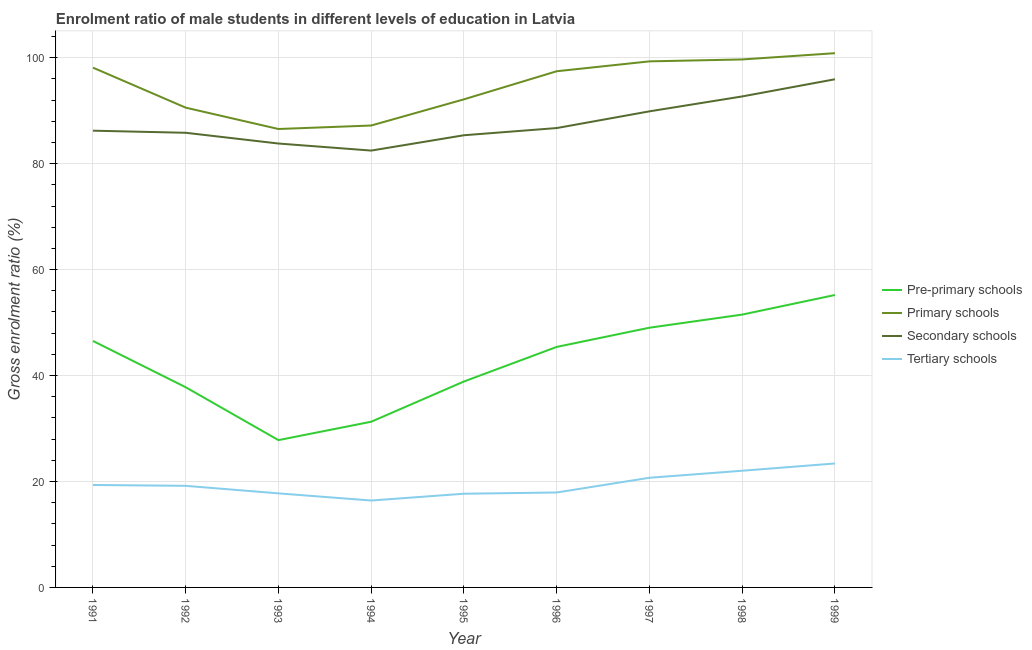How many different coloured lines are there?
Provide a succinct answer. 4. Is the number of lines equal to the number of legend labels?
Your answer should be very brief. Yes. What is the gross enrolment ratio(female) in secondary schools in 1993?
Offer a very short reply. 83.8. Across all years, what is the maximum gross enrolment ratio(female) in tertiary schools?
Give a very brief answer. 23.4. Across all years, what is the minimum gross enrolment ratio(female) in tertiary schools?
Offer a very short reply. 16.41. In which year was the gross enrolment ratio(female) in secondary schools minimum?
Offer a very short reply. 1994. What is the total gross enrolment ratio(female) in pre-primary schools in the graph?
Provide a short and direct response. 383.44. What is the difference between the gross enrolment ratio(female) in secondary schools in 1993 and that in 1998?
Offer a very short reply. -8.89. What is the difference between the gross enrolment ratio(female) in pre-primary schools in 1999 and the gross enrolment ratio(female) in secondary schools in 1998?
Offer a terse response. -37.49. What is the average gross enrolment ratio(female) in pre-primary schools per year?
Make the answer very short. 42.6. In the year 1991, what is the difference between the gross enrolment ratio(female) in pre-primary schools and gross enrolment ratio(female) in secondary schools?
Your answer should be compact. -39.69. In how many years, is the gross enrolment ratio(female) in primary schools greater than 16 %?
Your answer should be compact. 9. What is the ratio of the gross enrolment ratio(female) in tertiary schools in 1996 to that in 1997?
Make the answer very short. 0.87. What is the difference between the highest and the second highest gross enrolment ratio(female) in pre-primary schools?
Offer a terse response. 3.7. What is the difference between the highest and the lowest gross enrolment ratio(female) in tertiary schools?
Make the answer very short. 6.99. Is it the case that in every year, the sum of the gross enrolment ratio(female) in tertiary schools and gross enrolment ratio(female) in pre-primary schools is greater than the sum of gross enrolment ratio(female) in primary schools and gross enrolment ratio(female) in secondary schools?
Your response must be concise. No. Does the gross enrolment ratio(female) in tertiary schools monotonically increase over the years?
Offer a terse response. No. Is the gross enrolment ratio(female) in secondary schools strictly greater than the gross enrolment ratio(female) in tertiary schools over the years?
Your answer should be very brief. Yes. Is the gross enrolment ratio(female) in tertiary schools strictly less than the gross enrolment ratio(female) in pre-primary schools over the years?
Your response must be concise. Yes. Are the values on the major ticks of Y-axis written in scientific E-notation?
Give a very brief answer. No. Does the graph contain any zero values?
Your response must be concise. No. Does the graph contain grids?
Provide a short and direct response. Yes. How are the legend labels stacked?
Ensure brevity in your answer.  Vertical. What is the title of the graph?
Give a very brief answer. Enrolment ratio of male students in different levels of education in Latvia. Does "Labor Taxes" appear as one of the legend labels in the graph?
Your response must be concise. No. What is the label or title of the X-axis?
Make the answer very short. Year. What is the Gross enrolment ratio (%) in Pre-primary schools in 1991?
Make the answer very short. 46.53. What is the Gross enrolment ratio (%) of Primary schools in 1991?
Give a very brief answer. 98.13. What is the Gross enrolment ratio (%) in Secondary schools in 1991?
Make the answer very short. 86.23. What is the Gross enrolment ratio (%) in Tertiary schools in 1991?
Keep it short and to the point. 19.34. What is the Gross enrolment ratio (%) in Pre-primary schools in 1992?
Make the answer very short. 37.79. What is the Gross enrolment ratio (%) in Primary schools in 1992?
Your response must be concise. 90.57. What is the Gross enrolment ratio (%) in Secondary schools in 1992?
Your answer should be compact. 85.83. What is the Gross enrolment ratio (%) in Tertiary schools in 1992?
Provide a short and direct response. 19.18. What is the Gross enrolment ratio (%) of Pre-primary schools in 1993?
Your response must be concise. 27.81. What is the Gross enrolment ratio (%) of Primary schools in 1993?
Your answer should be compact. 86.54. What is the Gross enrolment ratio (%) in Secondary schools in 1993?
Offer a terse response. 83.8. What is the Gross enrolment ratio (%) of Tertiary schools in 1993?
Your response must be concise. 17.76. What is the Gross enrolment ratio (%) of Pre-primary schools in 1994?
Your answer should be very brief. 31.28. What is the Gross enrolment ratio (%) in Primary schools in 1994?
Your response must be concise. 87.2. What is the Gross enrolment ratio (%) of Secondary schools in 1994?
Make the answer very short. 82.47. What is the Gross enrolment ratio (%) of Tertiary schools in 1994?
Make the answer very short. 16.41. What is the Gross enrolment ratio (%) of Pre-primary schools in 1995?
Provide a short and direct response. 38.88. What is the Gross enrolment ratio (%) in Primary schools in 1995?
Offer a very short reply. 92.15. What is the Gross enrolment ratio (%) of Secondary schools in 1995?
Offer a very short reply. 85.37. What is the Gross enrolment ratio (%) of Tertiary schools in 1995?
Offer a very short reply. 17.69. What is the Gross enrolment ratio (%) in Pre-primary schools in 1996?
Ensure brevity in your answer.  45.4. What is the Gross enrolment ratio (%) of Primary schools in 1996?
Provide a short and direct response. 97.45. What is the Gross enrolment ratio (%) of Secondary schools in 1996?
Offer a terse response. 86.72. What is the Gross enrolment ratio (%) of Tertiary schools in 1996?
Offer a terse response. 17.92. What is the Gross enrolment ratio (%) in Pre-primary schools in 1997?
Your response must be concise. 49.03. What is the Gross enrolment ratio (%) in Primary schools in 1997?
Your answer should be compact. 99.31. What is the Gross enrolment ratio (%) in Secondary schools in 1997?
Provide a short and direct response. 89.88. What is the Gross enrolment ratio (%) in Tertiary schools in 1997?
Offer a very short reply. 20.7. What is the Gross enrolment ratio (%) of Pre-primary schools in 1998?
Your answer should be compact. 51.51. What is the Gross enrolment ratio (%) of Primary schools in 1998?
Offer a very short reply. 99.67. What is the Gross enrolment ratio (%) in Secondary schools in 1998?
Make the answer very short. 92.69. What is the Gross enrolment ratio (%) of Tertiary schools in 1998?
Ensure brevity in your answer.  22.03. What is the Gross enrolment ratio (%) in Pre-primary schools in 1999?
Your response must be concise. 55.2. What is the Gross enrolment ratio (%) in Primary schools in 1999?
Your answer should be compact. 100.86. What is the Gross enrolment ratio (%) in Secondary schools in 1999?
Keep it short and to the point. 95.93. What is the Gross enrolment ratio (%) in Tertiary schools in 1999?
Give a very brief answer. 23.4. Across all years, what is the maximum Gross enrolment ratio (%) of Pre-primary schools?
Your answer should be compact. 55.2. Across all years, what is the maximum Gross enrolment ratio (%) of Primary schools?
Offer a terse response. 100.86. Across all years, what is the maximum Gross enrolment ratio (%) in Secondary schools?
Offer a very short reply. 95.93. Across all years, what is the maximum Gross enrolment ratio (%) of Tertiary schools?
Provide a succinct answer. 23.4. Across all years, what is the minimum Gross enrolment ratio (%) of Pre-primary schools?
Provide a short and direct response. 27.81. Across all years, what is the minimum Gross enrolment ratio (%) in Primary schools?
Offer a terse response. 86.54. Across all years, what is the minimum Gross enrolment ratio (%) of Secondary schools?
Offer a terse response. 82.47. Across all years, what is the minimum Gross enrolment ratio (%) of Tertiary schools?
Provide a succinct answer. 16.41. What is the total Gross enrolment ratio (%) of Pre-primary schools in the graph?
Your answer should be compact. 383.44. What is the total Gross enrolment ratio (%) in Primary schools in the graph?
Provide a succinct answer. 851.88. What is the total Gross enrolment ratio (%) of Secondary schools in the graph?
Keep it short and to the point. 788.92. What is the total Gross enrolment ratio (%) of Tertiary schools in the graph?
Ensure brevity in your answer.  174.43. What is the difference between the Gross enrolment ratio (%) in Pre-primary schools in 1991 and that in 1992?
Ensure brevity in your answer.  8.74. What is the difference between the Gross enrolment ratio (%) in Primary schools in 1991 and that in 1992?
Offer a terse response. 7.55. What is the difference between the Gross enrolment ratio (%) of Secondary schools in 1991 and that in 1992?
Offer a terse response. 0.4. What is the difference between the Gross enrolment ratio (%) of Tertiary schools in 1991 and that in 1992?
Offer a very short reply. 0.16. What is the difference between the Gross enrolment ratio (%) in Pre-primary schools in 1991 and that in 1993?
Your answer should be compact. 18.72. What is the difference between the Gross enrolment ratio (%) of Primary schools in 1991 and that in 1993?
Give a very brief answer. 11.59. What is the difference between the Gross enrolment ratio (%) in Secondary schools in 1991 and that in 1993?
Keep it short and to the point. 2.42. What is the difference between the Gross enrolment ratio (%) in Tertiary schools in 1991 and that in 1993?
Give a very brief answer. 1.59. What is the difference between the Gross enrolment ratio (%) of Pre-primary schools in 1991 and that in 1994?
Make the answer very short. 15.25. What is the difference between the Gross enrolment ratio (%) of Primary schools in 1991 and that in 1994?
Offer a very short reply. 10.93. What is the difference between the Gross enrolment ratio (%) of Secondary schools in 1991 and that in 1994?
Your response must be concise. 3.76. What is the difference between the Gross enrolment ratio (%) of Tertiary schools in 1991 and that in 1994?
Offer a very short reply. 2.94. What is the difference between the Gross enrolment ratio (%) in Pre-primary schools in 1991 and that in 1995?
Keep it short and to the point. 7.66. What is the difference between the Gross enrolment ratio (%) in Primary schools in 1991 and that in 1995?
Your response must be concise. 5.98. What is the difference between the Gross enrolment ratio (%) of Secondary schools in 1991 and that in 1995?
Your response must be concise. 0.86. What is the difference between the Gross enrolment ratio (%) of Tertiary schools in 1991 and that in 1995?
Your answer should be compact. 1.65. What is the difference between the Gross enrolment ratio (%) in Pre-primary schools in 1991 and that in 1996?
Offer a very short reply. 1.13. What is the difference between the Gross enrolment ratio (%) in Primary schools in 1991 and that in 1996?
Give a very brief answer. 0.68. What is the difference between the Gross enrolment ratio (%) of Secondary schools in 1991 and that in 1996?
Keep it short and to the point. -0.5. What is the difference between the Gross enrolment ratio (%) in Tertiary schools in 1991 and that in 1996?
Provide a succinct answer. 1.42. What is the difference between the Gross enrolment ratio (%) in Pre-primary schools in 1991 and that in 1997?
Offer a very short reply. -2.5. What is the difference between the Gross enrolment ratio (%) in Primary schools in 1991 and that in 1997?
Your response must be concise. -1.19. What is the difference between the Gross enrolment ratio (%) in Secondary schools in 1991 and that in 1997?
Keep it short and to the point. -3.65. What is the difference between the Gross enrolment ratio (%) of Tertiary schools in 1991 and that in 1997?
Make the answer very short. -1.36. What is the difference between the Gross enrolment ratio (%) in Pre-primary schools in 1991 and that in 1998?
Keep it short and to the point. -4.98. What is the difference between the Gross enrolment ratio (%) in Primary schools in 1991 and that in 1998?
Ensure brevity in your answer.  -1.55. What is the difference between the Gross enrolment ratio (%) of Secondary schools in 1991 and that in 1998?
Keep it short and to the point. -6.47. What is the difference between the Gross enrolment ratio (%) in Tertiary schools in 1991 and that in 1998?
Keep it short and to the point. -2.69. What is the difference between the Gross enrolment ratio (%) in Pre-primary schools in 1991 and that in 1999?
Make the answer very short. -8.67. What is the difference between the Gross enrolment ratio (%) in Primary schools in 1991 and that in 1999?
Your response must be concise. -2.73. What is the difference between the Gross enrolment ratio (%) in Secondary schools in 1991 and that in 1999?
Your answer should be compact. -9.71. What is the difference between the Gross enrolment ratio (%) of Tertiary schools in 1991 and that in 1999?
Your response must be concise. -4.05. What is the difference between the Gross enrolment ratio (%) of Pre-primary schools in 1992 and that in 1993?
Keep it short and to the point. 9.99. What is the difference between the Gross enrolment ratio (%) in Primary schools in 1992 and that in 1993?
Your answer should be compact. 4.03. What is the difference between the Gross enrolment ratio (%) in Secondary schools in 1992 and that in 1993?
Provide a short and direct response. 2.03. What is the difference between the Gross enrolment ratio (%) in Tertiary schools in 1992 and that in 1993?
Offer a terse response. 1.42. What is the difference between the Gross enrolment ratio (%) in Pre-primary schools in 1992 and that in 1994?
Your answer should be compact. 6.51. What is the difference between the Gross enrolment ratio (%) of Primary schools in 1992 and that in 1994?
Your answer should be very brief. 3.37. What is the difference between the Gross enrolment ratio (%) of Secondary schools in 1992 and that in 1994?
Offer a very short reply. 3.36. What is the difference between the Gross enrolment ratio (%) of Tertiary schools in 1992 and that in 1994?
Offer a terse response. 2.77. What is the difference between the Gross enrolment ratio (%) of Pre-primary schools in 1992 and that in 1995?
Provide a succinct answer. -1.08. What is the difference between the Gross enrolment ratio (%) of Primary schools in 1992 and that in 1995?
Provide a short and direct response. -1.57. What is the difference between the Gross enrolment ratio (%) of Secondary schools in 1992 and that in 1995?
Your answer should be compact. 0.47. What is the difference between the Gross enrolment ratio (%) of Tertiary schools in 1992 and that in 1995?
Keep it short and to the point. 1.49. What is the difference between the Gross enrolment ratio (%) of Pre-primary schools in 1992 and that in 1996?
Keep it short and to the point. -7.61. What is the difference between the Gross enrolment ratio (%) of Primary schools in 1992 and that in 1996?
Keep it short and to the point. -6.87. What is the difference between the Gross enrolment ratio (%) in Secondary schools in 1992 and that in 1996?
Your response must be concise. -0.89. What is the difference between the Gross enrolment ratio (%) in Tertiary schools in 1992 and that in 1996?
Provide a short and direct response. 1.26. What is the difference between the Gross enrolment ratio (%) in Pre-primary schools in 1992 and that in 1997?
Provide a short and direct response. -11.24. What is the difference between the Gross enrolment ratio (%) in Primary schools in 1992 and that in 1997?
Make the answer very short. -8.74. What is the difference between the Gross enrolment ratio (%) in Secondary schools in 1992 and that in 1997?
Offer a terse response. -4.05. What is the difference between the Gross enrolment ratio (%) of Tertiary schools in 1992 and that in 1997?
Give a very brief answer. -1.52. What is the difference between the Gross enrolment ratio (%) in Pre-primary schools in 1992 and that in 1998?
Ensure brevity in your answer.  -13.71. What is the difference between the Gross enrolment ratio (%) of Primary schools in 1992 and that in 1998?
Offer a very short reply. -9.1. What is the difference between the Gross enrolment ratio (%) in Secondary schools in 1992 and that in 1998?
Offer a very short reply. -6.86. What is the difference between the Gross enrolment ratio (%) of Tertiary schools in 1992 and that in 1998?
Offer a terse response. -2.85. What is the difference between the Gross enrolment ratio (%) of Pre-primary schools in 1992 and that in 1999?
Your answer should be very brief. -17.41. What is the difference between the Gross enrolment ratio (%) in Primary schools in 1992 and that in 1999?
Provide a succinct answer. -10.28. What is the difference between the Gross enrolment ratio (%) in Secondary schools in 1992 and that in 1999?
Ensure brevity in your answer.  -10.1. What is the difference between the Gross enrolment ratio (%) of Tertiary schools in 1992 and that in 1999?
Make the answer very short. -4.22. What is the difference between the Gross enrolment ratio (%) in Pre-primary schools in 1993 and that in 1994?
Give a very brief answer. -3.47. What is the difference between the Gross enrolment ratio (%) of Primary schools in 1993 and that in 1994?
Your response must be concise. -0.66. What is the difference between the Gross enrolment ratio (%) in Secondary schools in 1993 and that in 1994?
Provide a succinct answer. 1.33. What is the difference between the Gross enrolment ratio (%) of Tertiary schools in 1993 and that in 1994?
Make the answer very short. 1.35. What is the difference between the Gross enrolment ratio (%) of Pre-primary schools in 1993 and that in 1995?
Your answer should be compact. -11.07. What is the difference between the Gross enrolment ratio (%) in Primary schools in 1993 and that in 1995?
Keep it short and to the point. -5.6. What is the difference between the Gross enrolment ratio (%) of Secondary schools in 1993 and that in 1995?
Offer a terse response. -1.56. What is the difference between the Gross enrolment ratio (%) of Tertiary schools in 1993 and that in 1995?
Offer a terse response. 0.07. What is the difference between the Gross enrolment ratio (%) in Pre-primary schools in 1993 and that in 1996?
Provide a short and direct response. -17.59. What is the difference between the Gross enrolment ratio (%) in Primary schools in 1993 and that in 1996?
Keep it short and to the point. -10.9. What is the difference between the Gross enrolment ratio (%) of Secondary schools in 1993 and that in 1996?
Ensure brevity in your answer.  -2.92. What is the difference between the Gross enrolment ratio (%) in Tertiary schools in 1993 and that in 1996?
Offer a very short reply. -0.17. What is the difference between the Gross enrolment ratio (%) of Pre-primary schools in 1993 and that in 1997?
Your response must be concise. -21.22. What is the difference between the Gross enrolment ratio (%) in Primary schools in 1993 and that in 1997?
Make the answer very short. -12.77. What is the difference between the Gross enrolment ratio (%) of Secondary schools in 1993 and that in 1997?
Your answer should be compact. -6.08. What is the difference between the Gross enrolment ratio (%) in Tertiary schools in 1993 and that in 1997?
Keep it short and to the point. -2.95. What is the difference between the Gross enrolment ratio (%) in Pre-primary schools in 1993 and that in 1998?
Ensure brevity in your answer.  -23.7. What is the difference between the Gross enrolment ratio (%) of Primary schools in 1993 and that in 1998?
Make the answer very short. -13.13. What is the difference between the Gross enrolment ratio (%) of Secondary schools in 1993 and that in 1998?
Keep it short and to the point. -8.89. What is the difference between the Gross enrolment ratio (%) of Tertiary schools in 1993 and that in 1998?
Provide a succinct answer. -4.27. What is the difference between the Gross enrolment ratio (%) in Pre-primary schools in 1993 and that in 1999?
Ensure brevity in your answer.  -27.39. What is the difference between the Gross enrolment ratio (%) in Primary schools in 1993 and that in 1999?
Your answer should be compact. -14.31. What is the difference between the Gross enrolment ratio (%) in Secondary schools in 1993 and that in 1999?
Make the answer very short. -12.13. What is the difference between the Gross enrolment ratio (%) in Tertiary schools in 1993 and that in 1999?
Your answer should be compact. -5.64. What is the difference between the Gross enrolment ratio (%) of Pre-primary schools in 1994 and that in 1995?
Your response must be concise. -7.6. What is the difference between the Gross enrolment ratio (%) of Primary schools in 1994 and that in 1995?
Make the answer very short. -4.94. What is the difference between the Gross enrolment ratio (%) in Secondary schools in 1994 and that in 1995?
Your response must be concise. -2.89. What is the difference between the Gross enrolment ratio (%) in Tertiary schools in 1994 and that in 1995?
Offer a terse response. -1.28. What is the difference between the Gross enrolment ratio (%) in Pre-primary schools in 1994 and that in 1996?
Offer a terse response. -14.12. What is the difference between the Gross enrolment ratio (%) of Primary schools in 1994 and that in 1996?
Offer a terse response. -10.24. What is the difference between the Gross enrolment ratio (%) in Secondary schools in 1994 and that in 1996?
Ensure brevity in your answer.  -4.25. What is the difference between the Gross enrolment ratio (%) in Tertiary schools in 1994 and that in 1996?
Ensure brevity in your answer.  -1.52. What is the difference between the Gross enrolment ratio (%) in Pre-primary schools in 1994 and that in 1997?
Keep it short and to the point. -17.75. What is the difference between the Gross enrolment ratio (%) in Primary schools in 1994 and that in 1997?
Provide a succinct answer. -12.11. What is the difference between the Gross enrolment ratio (%) in Secondary schools in 1994 and that in 1997?
Your response must be concise. -7.41. What is the difference between the Gross enrolment ratio (%) in Tertiary schools in 1994 and that in 1997?
Provide a short and direct response. -4.29. What is the difference between the Gross enrolment ratio (%) in Pre-primary schools in 1994 and that in 1998?
Give a very brief answer. -20.23. What is the difference between the Gross enrolment ratio (%) of Primary schools in 1994 and that in 1998?
Your answer should be compact. -12.47. What is the difference between the Gross enrolment ratio (%) in Secondary schools in 1994 and that in 1998?
Provide a succinct answer. -10.22. What is the difference between the Gross enrolment ratio (%) in Tertiary schools in 1994 and that in 1998?
Provide a succinct answer. -5.62. What is the difference between the Gross enrolment ratio (%) of Pre-primary schools in 1994 and that in 1999?
Offer a terse response. -23.92. What is the difference between the Gross enrolment ratio (%) in Primary schools in 1994 and that in 1999?
Give a very brief answer. -13.65. What is the difference between the Gross enrolment ratio (%) of Secondary schools in 1994 and that in 1999?
Make the answer very short. -13.46. What is the difference between the Gross enrolment ratio (%) of Tertiary schools in 1994 and that in 1999?
Make the answer very short. -6.99. What is the difference between the Gross enrolment ratio (%) of Pre-primary schools in 1995 and that in 1996?
Your answer should be compact. -6.53. What is the difference between the Gross enrolment ratio (%) in Primary schools in 1995 and that in 1996?
Your answer should be compact. -5.3. What is the difference between the Gross enrolment ratio (%) in Secondary schools in 1995 and that in 1996?
Your answer should be compact. -1.36. What is the difference between the Gross enrolment ratio (%) of Tertiary schools in 1995 and that in 1996?
Your answer should be very brief. -0.23. What is the difference between the Gross enrolment ratio (%) in Pre-primary schools in 1995 and that in 1997?
Your answer should be very brief. -10.15. What is the difference between the Gross enrolment ratio (%) of Primary schools in 1995 and that in 1997?
Your answer should be very brief. -7.17. What is the difference between the Gross enrolment ratio (%) of Secondary schools in 1995 and that in 1997?
Offer a very short reply. -4.51. What is the difference between the Gross enrolment ratio (%) in Tertiary schools in 1995 and that in 1997?
Your answer should be very brief. -3.01. What is the difference between the Gross enrolment ratio (%) in Pre-primary schools in 1995 and that in 1998?
Provide a short and direct response. -12.63. What is the difference between the Gross enrolment ratio (%) in Primary schools in 1995 and that in 1998?
Give a very brief answer. -7.53. What is the difference between the Gross enrolment ratio (%) of Secondary schools in 1995 and that in 1998?
Offer a very short reply. -7.33. What is the difference between the Gross enrolment ratio (%) in Tertiary schools in 1995 and that in 1998?
Your answer should be compact. -4.34. What is the difference between the Gross enrolment ratio (%) of Pre-primary schools in 1995 and that in 1999?
Give a very brief answer. -16.33. What is the difference between the Gross enrolment ratio (%) in Primary schools in 1995 and that in 1999?
Your response must be concise. -8.71. What is the difference between the Gross enrolment ratio (%) of Secondary schools in 1995 and that in 1999?
Your answer should be compact. -10.57. What is the difference between the Gross enrolment ratio (%) in Tertiary schools in 1995 and that in 1999?
Keep it short and to the point. -5.71. What is the difference between the Gross enrolment ratio (%) of Pre-primary schools in 1996 and that in 1997?
Keep it short and to the point. -3.63. What is the difference between the Gross enrolment ratio (%) in Primary schools in 1996 and that in 1997?
Your answer should be compact. -1.87. What is the difference between the Gross enrolment ratio (%) in Secondary schools in 1996 and that in 1997?
Give a very brief answer. -3.16. What is the difference between the Gross enrolment ratio (%) of Tertiary schools in 1996 and that in 1997?
Give a very brief answer. -2.78. What is the difference between the Gross enrolment ratio (%) of Pre-primary schools in 1996 and that in 1998?
Keep it short and to the point. -6.1. What is the difference between the Gross enrolment ratio (%) of Primary schools in 1996 and that in 1998?
Your answer should be compact. -2.23. What is the difference between the Gross enrolment ratio (%) of Secondary schools in 1996 and that in 1998?
Provide a short and direct response. -5.97. What is the difference between the Gross enrolment ratio (%) of Tertiary schools in 1996 and that in 1998?
Provide a succinct answer. -4.11. What is the difference between the Gross enrolment ratio (%) of Pre-primary schools in 1996 and that in 1999?
Provide a succinct answer. -9.8. What is the difference between the Gross enrolment ratio (%) of Primary schools in 1996 and that in 1999?
Your answer should be very brief. -3.41. What is the difference between the Gross enrolment ratio (%) in Secondary schools in 1996 and that in 1999?
Make the answer very short. -9.21. What is the difference between the Gross enrolment ratio (%) in Tertiary schools in 1996 and that in 1999?
Your answer should be very brief. -5.48. What is the difference between the Gross enrolment ratio (%) of Pre-primary schools in 1997 and that in 1998?
Offer a very short reply. -2.48. What is the difference between the Gross enrolment ratio (%) in Primary schools in 1997 and that in 1998?
Your answer should be very brief. -0.36. What is the difference between the Gross enrolment ratio (%) in Secondary schools in 1997 and that in 1998?
Your response must be concise. -2.81. What is the difference between the Gross enrolment ratio (%) of Tertiary schools in 1997 and that in 1998?
Provide a succinct answer. -1.33. What is the difference between the Gross enrolment ratio (%) in Pre-primary schools in 1997 and that in 1999?
Provide a short and direct response. -6.17. What is the difference between the Gross enrolment ratio (%) of Primary schools in 1997 and that in 1999?
Make the answer very short. -1.54. What is the difference between the Gross enrolment ratio (%) of Secondary schools in 1997 and that in 1999?
Your response must be concise. -6.05. What is the difference between the Gross enrolment ratio (%) of Tertiary schools in 1997 and that in 1999?
Your answer should be compact. -2.7. What is the difference between the Gross enrolment ratio (%) in Pre-primary schools in 1998 and that in 1999?
Provide a short and direct response. -3.7. What is the difference between the Gross enrolment ratio (%) in Primary schools in 1998 and that in 1999?
Make the answer very short. -1.18. What is the difference between the Gross enrolment ratio (%) in Secondary schools in 1998 and that in 1999?
Ensure brevity in your answer.  -3.24. What is the difference between the Gross enrolment ratio (%) of Tertiary schools in 1998 and that in 1999?
Keep it short and to the point. -1.37. What is the difference between the Gross enrolment ratio (%) of Pre-primary schools in 1991 and the Gross enrolment ratio (%) of Primary schools in 1992?
Provide a succinct answer. -44.04. What is the difference between the Gross enrolment ratio (%) in Pre-primary schools in 1991 and the Gross enrolment ratio (%) in Secondary schools in 1992?
Provide a succinct answer. -39.3. What is the difference between the Gross enrolment ratio (%) in Pre-primary schools in 1991 and the Gross enrolment ratio (%) in Tertiary schools in 1992?
Your answer should be very brief. 27.35. What is the difference between the Gross enrolment ratio (%) of Primary schools in 1991 and the Gross enrolment ratio (%) of Secondary schools in 1992?
Make the answer very short. 12.3. What is the difference between the Gross enrolment ratio (%) in Primary schools in 1991 and the Gross enrolment ratio (%) in Tertiary schools in 1992?
Make the answer very short. 78.95. What is the difference between the Gross enrolment ratio (%) in Secondary schools in 1991 and the Gross enrolment ratio (%) in Tertiary schools in 1992?
Make the answer very short. 67.05. What is the difference between the Gross enrolment ratio (%) of Pre-primary schools in 1991 and the Gross enrolment ratio (%) of Primary schools in 1993?
Provide a short and direct response. -40.01. What is the difference between the Gross enrolment ratio (%) in Pre-primary schools in 1991 and the Gross enrolment ratio (%) in Secondary schools in 1993?
Keep it short and to the point. -37.27. What is the difference between the Gross enrolment ratio (%) in Pre-primary schools in 1991 and the Gross enrolment ratio (%) in Tertiary schools in 1993?
Your answer should be very brief. 28.78. What is the difference between the Gross enrolment ratio (%) in Primary schools in 1991 and the Gross enrolment ratio (%) in Secondary schools in 1993?
Keep it short and to the point. 14.32. What is the difference between the Gross enrolment ratio (%) in Primary schools in 1991 and the Gross enrolment ratio (%) in Tertiary schools in 1993?
Provide a short and direct response. 80.37. What is the difference between the Gross enrolment ratio (%) of Secondary schools in 1991 and the Gross enrolment ratio (%) of Tertiary schools in 1993?
Offer a very short reply. 68.47. What is the difference between the Gross enrolment ratio (%) of Pre-primary schools in 1991 and the Gross enrolment ratio (%) of Primary schools in 1994?
Make the answer very short. -40.67. What is the difference between the Gross enrolment ratio (%) in Pre-primary schools in 1991 and the Gross enrolment ratio (%) in Secondary schools in 1994?
Keep it short and to the point. -35.94. What is the difference between the Gross enrolment ratio (%) in Pre-primary schools in 1991 and the Gross enrolment ratio (%) in Tertiary schools in 1994?
Make the answer very short. 30.12. What is the difference between the Gross enrolment ratio (%) in Primary schools in 1991 and the Gross enrolment ratio (%) in Secondary schools in 1994?
Make the answer very short. 15.66. What is the difference between the Gross enrolment ratio (%) in Primary schools in 1991 and the Gross enrolment ratio (%) in Tertiary schools in 1994?
Give a very brief answer. 81.72. What is the difference between the Gross enrolment ratio (%) in Secondary schools in 1991 and the Gross enrolment ratio (%) in Tertiary schools in 1994?
Ensure brevity in your answer.  69.82. What is the difference between the Gross enrolment ratio (%) of Pre-primary schools in 1991 and the Gross enrolment ratio (%) of Primary schools in 1995?
Offer a terse response. -45.61. What is the difference between the Gross enrolment ratio (%) in Pre-primary schools in 1991 and the Gross enrolment ratio (%) in Secondary schools in 1995?
Make the answer very short. -38.83. What is the difference between the Gross enrolment ratio (%) in Pre-primary schools in 1991 and the Gross enrolment ratio (%) in Tertiary schools in 1995?
Make the answer very short. 28.84. What is the difference between the Gross enrolment ratio (%) in Primary schools in 1991 and the Gross enrolment ratio (%) in Secondary schools in 1995?
Your answer should be compact. 12.76. What is the difference between the Gross enrolment ratio (%) in Primary schools in 1991 and the Gross enrolment ratio (%) in Tertiary schools in 1995?
Provide a succinct answer. 80.44. What is the difference between the Gross enrolment ratio (%) in Secondary schools in 1991 and the Gross enrolment ratio (%) in Tertiary schools in 1995?
Offer a very short reply. 68.54. What is the difference between the Gross enrolment ratio (%) of Pre-primary schools in 1991 and the Gross enrolment ratio (%) of Primary schools in 1996?
Offer a very short reply. -50.91. What is the difference between the Gross enrolment ratio (%) of Pre-primary schools in 1991 and the Gross enrolment ratio (%) of Secondary schools in 1996?
Your answer should be compact. -40.19. What is the difference between the Gross enrolment ratio (%) of Pre-primary schools in 1991 and the Gross enrolment ratio (%) of Tertiary schools in 1996?
Your response must be concise. 28.61. What is the difference between the Gross enrolment ratio (%) of Primary schools in 1991 and the Gross enrolment ratio (%) of Secondary schools in 1996?
Your response must be concise. 11.41. What is the difference between the Gross enrolment ratio (%) in Primary schools in 1991 and the Gross enrolment ratio (%) in Tertiary schools in 1996?
Make the answer very short. 80.2. What is the difference between the Gross enrolment ratio (%) in Secondary schools in 1991 and the Gross enrolment ratio (%) in Tertiary schools in 1996?
Offer a terse response. 68.3. What is the difference between the Gross enrolment ratio (%) of Pre-primary schools in 1991 and the Gross enrolment ratio (%) of Primary schools in 1997?
Provide a succinct answer. -52.78. What is the difference between the Gross enrolment ratio (%) in Pre-primary schools in 1991 and the Gross enrolment ratio (%) in Secondary schools in 1997?
Ensure brevity in your answer.  -43.35. What is the difference between the Gross enrolment ratio (%) in Pre-primary schools in 1991 and the Gross enrolment ratio (%) in Tertiary schools in 1997?
Ensure brevity in your answer.  25.83. What is the difference between the Gross enrolment ratio (%) of Primary schools in 1991 and the Gross enrolment ratio (%) of Secondary schools in 1997?
Your answer should be compact. 8.25. What is the difference between the Gross enrolment ratio (%) of Primary schools in 1991 and the Gross enrolment ratio (%) of Tertiary schools in 1997?
Make the answer very short. 77.43. What is the difference between the Gross enrolment ratio (%) in Secondary schools in 1991 and the Gross enrolment ratio (%) in Tertiary schools in 1997?
Your response must be concise. 65.52. What is the difference between the Gross enrolment ratio (%) in Pre-primary schools in 1991 and the Gross enrolment ratio (%) in Primary schools in 1998?
Provide a succinct answer. -53.14. What is the difference between the Gross enrolment ratio (%) in Pre-primary schools in 1991 and the Gross enrolment ratio (%) in Secondary schools in 1998?
Provide a short and direct response. -46.16. What is the difference between the Gross enrolment ratio (%) in Pre-primary schools in 1991 and the Gross enrolment ratio (%) in Tertiary schools in 1998?
Offer a very short reply. 24.5. What is the difference between the Gross enrolment ratio (%) in Primary schools in 1991 and the Gross enrolment ratio (%) in Secondary schools in 1998?
Provide a succinct answer. 5.44. What is the difference between the Gross enrolment ratio (%) in Primary schools in 1991 and the Gross enrolment ratio (%) in Tertiary schools in 1998?
Your response must be concise. 76.1. What is the difference between the Gross enrolment ratio (%) in Secondary schools in 1991 and the Gross enrolment ratio (%) in Tertiary schools in 1998?
Provide a short and direct response. 64.2. What is the difference between the Gross enrolment ratio (%) in Pre-primary schools in 1991 and the Gross enrolment ratio (%) in Primary schools in 1999?
Keep it short and to the point. -54.32. What is the difference between the Gross enrolment ratio (%) of Pre-primary schools in 1991 and the Gross enrolment ratio (%) of Secondary schools in 1999?
Your answer should be very brief. -49.4. What is the difference between the Gross enrolment ratio (%) in Pre-primary schools in 1991 and the Gross enrolment ratio (%) in Tertiary schools in 1999?
Offer a very short reply. 23.13. What is the difference between the Gross enrolment ratio (%) in Primary schools in 1991 and the Gross enrolment ratio (%) in Secondary schools in 1999?
Provide a short and direct response. 2.2. What is the difference between the Gross enrolment ratio (%) in Primary schools in 1991 and the Gross enrolment ratio (%) in Tertiary schools in 1999?
Your answer should be very brief. 74.73. What is the difference between the Gross enrolment ratio (%) of Secondary schools in 1991 and the Gross enrolment ratio (%) of Tertiary schools in 1999?
Provide a succinct answer. 62.83. What is the difference between the Gross enrolment ratio (%) in Pre-primary schools in 1992 and the Gross enrolment ratio (%) in Primary schools in 1993?
Your answer should be very brief. -48.75. What is the difference between the Gross enrolment ratio (%) of Pre-primary schools in 1992 and the Gross enrolment ratio (%) of Secondary schools in 1993?
Provide a succinct answer. -46.01. What is the difference between the Gross enrolment ratio (%) of Pre-primary schools in 1992 and the Gross enrolment ratio (%) of Tertiary schools in 1993?
Keep it short and to the point. 20.04. What is the difference between the Gross enrolment ratio (%) in Primary schools in 1992 and the Gross enrolment ratio (%) in Secondary schools in 1993?
Offer a very short reply. 6.77. What is the difference between the Gross enrolment ratio (%) in Primary schools in 1992 and the Gross enrolment ratio (%) in Tertiary schools in 1993?
Your answer should be compact. 72.82. What is the difference between the Gross enrolment ratio (%) in Secondary schools in 1992 and the Gross enrolment ratio (%) in Tertiary schools in 1993?
Your answer should be compact. 68.07. What is the difference between the Gross enrolment ratio (%) of Pre-primary schools in 1992 and the Gross enrolment ratio (%) of Primary schools in 1994?
Give a very brief answer. -49.41. What is the difference between the Gross enrolment ratio (%) in Pre-primary schools in 1992 and the Gross enrolment ratio (%) in Secondary schools in 1994?
Your answer should be very brief. -44.68. What is the difference between the Gross enrolment ratio (%) of Pre-primary schools in 1992 and the Gross enrolment ratio (%) of Tertiary schools in 1994?
Make the answer very short. 21.39. What is the difference between the Gross enrolment ratio (%) of Primary schools in 1992 and the Gross enrolment ratio (%) of Secondary schools in 1994?
Your answer should be compact. 8.1. What is the difference between the Gross enrolment ratio (%) in Primary schools in 1992 and the Gross enrolment ratio (%) in Tertiary schools in 1994?
Your answer should be compact. 74.17. What is the difference between the Gross enrolment ratio (%) of Secondary schools in 1992 and the Gross enrolment ratio (%) of Tertiary schools in 1994?
Your answer should be compact. 69.42. What is the difference between the Gross enrolment ratio (%) of Pre-primary schools in 1992 and the Gross enrolment ratio (%) of Primary schools in 1995?
Make the answer very short. -54.35. What is the difference between the Gross enrolment ratio (%) in Pre-primary schools in 1992 and the Gross enrolment ratio (%) in Secondary schools in 1995?
Offer a very short reply. -47.57. What is the difference between the Gross enrolment ratio (%) of Pre-primary schools in 1992 and the Gross enrolment ratio (%) of Tertiary schools in 1995?
Your answer should be very brief. 20.11. What is the difference between the Gross enrolment ratio (%) of Primary schools in 1992 and the Gross enrolment ratio (%) of Secondary schools in 1995?
Your answer should be very brief. 5.21. What is the difference between the Gross enrolment ratio (%) in Primary schools in 1992 and the Gross enrolment ratio (%) in Tertiary schools in 1995?
Your answer should be very brief. 72.89. What is the difference between the Gross enrolment ratio (%) in Secondary schools in 1992 and the Gross enrolment ratio (%) in Tertiary schools in 1995?
Ensure brevity in your answer.  68.14. What is the difference between the Gross enrolment ratio (%) in Pre-primary schools in 1992 and the Gross enrolment ratio (%) in Primary schools in 1996?
Make the answer very short. -59.65. What is the difference between the Gross enrolment ratio (%) in Pre-primary schools in 1992 and the Gross enrolment ratio (%) in Secondary schools in 1996?
Offer a terse response. -48.93. What is the difference between the Gross enrolment ratio (%) of Pre-primary schools in 1992 and the Gross enrolment ratio (%) of Tertiary schools in 1996?
Make the answer very short. 19.87. What is the difference between the Gross enrolment ratio (%) in Primary schools in 1992 and the Gross enrolment ratio (%) in Secondary schools in 1996?
Provide a short and direct response. 3.85. What is the difference between the Gross enrolment ratio (%) in Primary schools in 1992 and the Gross enrolment ratio (%) in Tertiary schools in 1996?
Give a very brief answer. 72.65. What is the difference between the Gross enrolment ratio (%) of Secondary schools in 1992 and the Gross enrolment ratio (%) of Tertiary schools in 1996?
Provide a succinct answer. 67.91. What is the difference between the Gross enrolment ratio (%) in Pre-primary schools in 1992 and the Gross enrolment ratio (%) in Primary schools in 1997?
Your answer should be compact. -61.52. What is the difference between the Gross enrolment ratio (%) in Pre-primary schools in 1992 and the Gross enrolment ratio (%) in Secondary schools in 1997?
Give a very brief answer. -52.08. What is the difference between the Gross enrolment ratio (%) in Pre-primary schools in 1992 and the Gross enrolment ratio (%) in Tertiary schools in 1997?
Your answer should be very brief. 17.09. What is the difference between the Gross enrolment ratio (%) of Primary schools in 1992 and the Gross enrolment ratio (%) of Secondary schools in 1997?
Keep it short and to the point. 0.7. What is the difference between the Gross enrolment ratio (%) in Primary schools in 1992 and the Gross enrolment ratio (%) in Tertiary schools in 1997?
Make the answer very short. 69.87. What is the difference between the Gross enrolment ratio (%) in Secondary schools in 1992 and the Gross enrolment ratio (%) in Tertiary schools in 1997?
Ensure brevity in your answer.  65.13. What is the difference between the Gross enrolment ratio (%) of Pre-primary schools in 1992 and the Gross enrolment ratio (%) of Primary schools in 1998?
Offer a terse response. -61.88. What is the difference between the Gross enrolment ratio (%) of Pre-primary schools in 1992 and the Gross enrolment ratio (%) of Secondary schools in 1998?
Ensure brevity in your answer.  -54.9. What is the difference between the Gross enrolment ratio (%) in Pre-primary schools in 1992 and the Gross enrolment ratio (%) in Tertiary schools in 1998?
Ensure brevity in your answer.  15.76. What is the difference between the Gross enrolment ratio (%) in Primary schools in 1992 and the Gross enrolment ratio (%) in Secondary schools in 1998?
Your answer should be compact. -2.12. What is the difference between the Gross enrolment ratio (%) in Primary schools in 1992 and the Gross enrolment ratio (%) in Tertiary schools in 1998?
Your answer should be very brief. 68.54. What is the difference between the Gross enrolment ratio (%) in Secondary schools in 1992 and the Gross enrolment ratio (%) in Tertiary schools in 1998?
Offer a very short reply. 63.8. What is the difference between the Gross enrolment ratio (%) of Pre-primary schools in 1992 and the Gross enrolment ratio (%) of Primary schools in 1999?
Your response must be concise. -63.06. What is the difference between the Gross enrolment ratio (%) in Pre-primary schools in 1992 and the Gross enrolment ratio (%) in Secondary schools in 1999?
Your answer should be compact. -58.14. What is the difference between the Gross enrolment ratio (%) of Pre-primary schools in 1992 and the Gross enrolment ratio (%) of Tertiary schools in 1999?
Give a very brief answer. 14.4. What is the difference between the Gross enrolment ratio (%) of Primary schools in 1992 and the Gross enrolment ratio (%) of Secondary schools in 1999?
Keep it short and to the point. -5.36. What is the difference between the Gross enrolment ratio (%) of Primary schools in 1992 and the Gross enrolment ratio (%) of Tertiary schools in 1999?
Give a very brief answer. 67.18. What is the difference between the Gross enrolment ratio (%) in Secondary schools in 1992 and the Gross enrolment ratio (%) in Tertiary schools in 1999?
Offer a terse response. 62.43. What is the difference between the Gross enrolment ratio (%) of Pre-primary schools in 1993 and the Gross enrolment ratio (%) of Primary schools in 1994?
Provide a short and direct response. -59.39. What is the difference between the Gross enrolment ratio (%) in Pre-primary schools in 1993 and the Gross enrolment ratio (%) in Secondary schools in 1994?
Provide a succinct answer. -54.66. What is the difference between the Gross enrolment ratio (%) in Pre-primary schools in 1993 and the Gross enrolment ratio (%) in Tertiary schools in 1994?
Give a very brief answer. 11.4. What is the difference between the Gross enrolment ratio (%) in Primary schools in 1993 and the Gross enrolment ratio (%) in Secondary schools in 1994?
Your answer should be very brief. 4.07. What is the difference between the Gross enrolment ratio (%) in Primary schools in 1993 and the Gross enrolment ratio (%) in Tertiary schools in 1994?
Make the answer very short. 70.13. What is the difference between the Gross enrolment ratio (%) of Secondary schools in 1993 and the Gross enrolment ratio (%) of Tertiary schools in 1994?
Offer a terse response. 67.39. What is the difference between the Gross enrolment ratio (%) of Pre-primary schools in 1993 and the Gross enrolment ratio (%) of Primary schools in 1995?
Your answer should be very brief. -64.34. What is the difference between the Gross enrolment ratio (%) of Pre-primary schools in 1993 and the Gross enrolment ratio (%) of Secondary schools in 1995?
Offer a terse response. -57.56. What is the difference between the Gross enrolment ratio (%) of Pre-primary schools in 1993 and the Gross enrolment ratio (%) of Tertiary schools in 1995?
Your answer should be very brief. 10.12. What is the difference between the Gross enrolment ratio (%) of Primary schools in 1993 and the Gross enrolment ratio (%) of Secondary schools in 1995?
Ensure brevity in your answer.  1.18. What is the difference between the Gross enrolment ratio (%) of Primary schools in 1993 and the Gross enrolment ratio (%) of Tertiary schools in 1995?
Your answer should be compact. 68.85. What is the difference between the Gross enrolment ratio (%) in Secondary schools in 1993 and the Gross enrolment ratio (%) in Tertiary schools in 1995?
Provide a succinct answer. 66.11. What is the difference between the Gross enrolment ratio (%) of Pre-primary schools in 1993 and the Gross enrolment ratio (%) of Primary schools in 1996?
Offer a terse response. -69.64. What is the difference between the Gross enrolment ratio (%) in Pre-primary schools in 1993 and the Gross enrolment ratio (%) in Secondary schools in 1996?
Your answer should be very brief. -58.91. What is the difference between the Gross enrolment ratio (%) in Pre-primary schools in 1993 and the Gross enrolment ratio (%) in Tertiary schools in 1996?
Offer a very short reply. 9.89. What is the difference between the Gross enrolment ratio (%) in Primary schools in 1993 and the Gross enrolment ratio (%) in Secondary schools in 1996?
Keep it short and to the point. -0.18. What is the difference between the Gross enrolment ratio (%) of Primary schools in 1993 and the Gross enrolment ratio (%) of Tertiary schools in 1996?
Make the answer very short. 68.62. What is the difference between the Gross enrolment ratio (%) in Secondary schools in 1993 and the Gross enrolment ratio (%) in Tertiary schools in 1996?
Offer a terse response. 65.88. What is the difference between the Gross enrolment ratio (%) in Pre-primary schools in 1993 and the Gross enrolment ratio (%) in Primary schools in 1997?
Ensure brevity in your answer.  -71.5. What is the difference between the Gross enrolment ratio (%) of Pre-primary schools in 1993 and the Gross enrolment ratio (%) of Secondary schools in 1997?
Make the answer very short. -62.07. What is the difference between the Gross enrolment ratio (%) of Pre-primary schools in 1993 and the Gross enrolment ratio (%) of Tertiary schools in 1997?
Keep it short and to the point. 7.11. What is the difference between the Gross enrolment ratio (%) of Primary schools in 1993 and the Gross enrolment ratio (%) of Secondary schools in 1997?
Keep it short and to the point. -3.34. What is the difference between the Gross enrolment ratio (%) of Primary schools in 1993 and the Gross enrolment ratio (%) of Tertiary schools in 1997?
Keep it short and to the point. 65.84. What is the difference between the Gross enrolment ratio (%) in Secondary schools in 1993 and the Gross enrolment ratio (%) in Tertiary schools in 1997?
Provide a succinct answer. 63.1. What is the difference between the Gross enrolment ratio (%) in Pre-primary schools in 1993 and the Gross enrolment ratio (%) in Primary schools in 1998?
Provide a short and direct response. -71.86. What is the difference between the Gross enrolment ratio (%) of Pre-primary schools in 1993 and the Gross enrolment ratio (%) of Secondary schools in 1998?
Keep it short and to the point. -64.88. What is the difference between the Gross enrolment ratio (%) of Pre-primary schools in 1993 and the Gross enrolment ratio (%) of Tertiary schools in 1998?
Provide a succinct answer. 5.78. What is the difference between the Gross enrolment ratio (%) of Primary schools in 1993 and the Gross enrolment ratio (%) of Secondary schools in 1998?
Your answer should be very brief. -6.15. What is the difference between the Gross enrolment ratio (%) in Primary schools in 1993 and the Gross enrolment ratio (%) in Tertiary schools in 1998?
Keep it short and to the point. 64.51. What is the difference between the Gross enrolment ratio (%) in Secondary schools in 1993 and the Gross enrolment ratio (%) in Tertiary schools in 1998?
Provide a short and direct response. 61.77. What is the difference between the Gross enrolment ratio (%) of Pre-primary schools in 1993 and the Gross enrolment ratio (%) of Primary schools in 1999?
Your response must be concise. -73.05. What is the difference between the Gross enrolment ratio (%) in Pre-primary schools in 1993 and the Gross enrolment ratio (%) in Secondary schools in 1999?
Make the answer very short. -68.12. What is the difference between the Gross enrolment ratio (%) of Pre-primary schools in 1993 and the Gross enrolment ratio (%) of Tertiary schools in 1999?
Your response must be concise. 4.41. What is the difference between the Gross enrolment ratio (%) of Primary schools in 1993 and the Gross enrolment ratio (%) of Secondary schools in 1999?
Give a very brief answer. -9.39. What is the difference between the Gross enrolment ratio (%) in Primary schools in 1993 and the Gross enrolment ratio (%) in Tertiary schools in 1999?
Ensure brevity in your answer.  63.14. What is the difference between the Gross enrolment ratio (%) in Secondary schools in 1993 and the Gross enrolment ratio (%) in Tertiary schools in 1999?
Provide a short and direct response. 60.4. What is the difference between the Gross enrolment ratio (%) in Pre-primary schools in 1994 and the Gross enrolment ratio (%) in Primary schools in 1995?
Keep it short and to the point. -60.86. What is the difference between the Gross enrolment ratio (%) of Pre-primary schools in 1994 and the Gross enrolment ratio (%) of Secondary schools in 1995?
Keep it short and to the point. -54.08. What is the difference between the Gross enrolment ratio (%) of Pre-primary schools in 1994 and the Gross enrolment ratio (%) of Tertiary schools in 1995?
Your answer should be compact. 13.59. What is the difference between the Gross enrolment ratio (%) of Primary schools in 1994 and the Gross enrolment ratio (%) of Secondary schools in 1995?
Your answer should be very brief. 1.84. What is the difference between the Gross enrolment ratio (%) of Primary schools in 1994 and the Gross enrolment ratio (%) of Tertiary schools in 1995?
Give a very brief answer. 69.51. What is the difference between the Gross enrolment ratio (%) in Secondary schools in 1994 and the Gross enrolment ratio (%) in Tertiary schools in 1995?
Ensure brevity in your answer.  64.78. What is the difference between the Gross enrolment ratio (%) in Pre-primary schools in 1994 and the Gross enrolment ratio (%) in Primary schools in 1996?
Provide a short and direct response. -66.17. What is the difference between the Gross enrolment ratio (%) in Pre-primary schools in 1994 and the Gross enrolment ratio (%) in Secondary schools in 1996?
Your response must be concise. -55.44. What is the difference between the Gross enrolment ratio (%) of Pre-primary schools in 1994 and the Gross enrolment ratio (%) of Tertiary schools in 1996?
Make the answer very short. 13.36. What is the difference between the Gross enrolment ratio (%) in Primary schools in 1994 and the Gross enrolment ratio (%) in Secondary schools in 1996?
Your answer should be very brief. 0.48. What is the difference between the Gross enrolment ratio (%) of Primary schools in 1994 and the Gross enrolment ratio (%) of Tertiary schools in 1996?
Keep it short and to the point. 69.28. What is the difference between the Gross enrolment ratio (%) in Secondary schools in 1994 and the Gross enrolment ratio (%) in Tertiary schools in 1996?
Make the answer very short. 64.55. What is the difference between the Gross enrolment ratio (%) of Pre-primary schools in 1994 and the Gross enrolment ratio (%) of Primary schools in 1997?
Offer a very short reply. -68.03. What is the difference between the Gross enrolment ratio (%) in Pre-primary schools in 1994 and the Gross enrolment ratio (%) in Secondary schools in 1997?
Your answer should be very brief. -58.6. What is the difference between the Gross enrolment ratio (%) of Pre-primary schools in 1994 and the Gross enrolment ratio (%) of Tertiary schools in 1997?
Make the answer very short. 10.58. What is the difference between the Gross enrolment ratio (%) in Primary schools in 1994 and the Gross enrolment ratio (%) in Secondary schools in 1997?
Offer a very short reply. -2.68. What is the difference between the Gross enrolment ratio (%) in Primary schools in 1994 and the Gross enrolment ratio (%) in Tertiary schools in 1997?
Offer a very short reply. 66.5. What is the difference between the Gross enrolment ratio (%) in Secondary schools in 1994 and the Gross enrolment ratio (%) in Tertiary schools in 1997?
Ensure brevity in your answer.  61.77. What is the difference between the Gross enrolment ratio (%) of Pre-primary schools in 1994 and the Gross enrolment ratio (%) of Primary schools in 1998?
Offer a very short reply. -68.39. What is the difference between the Gross enrolment ratio (%) in Pre-primary schools in 1994 and the Gross enrolment ratio (%) in Secondary schools in 1998?
Keep it short and to the point. -61.41. What is the difference between the Gross enrolment ratio (%) in Pre-primary schools in 1994 and the Gross enrolment ratio (%) in Tertiary schools in 1998?
Provide a succinct answer. 9.25. What is the difference between the Gross enrolment ratio (%) in Primary schools in 1994 and the Gross enrolment ratio (%) in Secondary schools in 1998?
Your answer should be compact. -5.49. What is the difference between the Gross enrolment ratio (%) of Primary schools in 1994 and the Gross enrolment ratio (%) of Tertiary schools in 1998?
Provide a succinct answer. 65.17. What is the difference between the Gross enrolment ratio (%) in Secondary schools in 1994 and the Gross enrolment ratio (%) in Tertiary schools in 1998?
Provide a succinct answer. 60.44. What is the difference between the Gross enrolment ratio (%) of Pre-primary schools in 1994 and the Gross enrolment ratio (%) of Primary schools in 1999?
Offer a terse response. -69.58. What is the difference between the Gross enrolment ratio (%) of Pre-primary schools in 1994 and the Gross enrolment ratio (%) of Secondary schools in 1999?
Offer a very short reply. -64.65. What is the difference between the Gross enrolment ratio (%) of Pre-primary schools in 1994 and the Gross enrolment ratio (%) of Tertiary schools in 1999?
Keep it short and to the point. 7.88. What is the difference between the Gross enrolment ratio (%) in Primary schools in 1994 and the Gross enrolment ratio (%) in Secondary schools in 1999?
Your response must be concise. -8.73. What is the difference between the Gross enrolment ratio (%) in Primary schools in 1994 and the Gross enrolment ratio (%) in Tertiary schools in 1999?
Your answer should be very brief. 63.8. What is the difference between the Gross enrolment ratio (%) in Secondary schools in 1994 and the Gross enrolment ratio (%) in Tertiary schools in 1999?
Ensure brevity in your answer.  59.07. What is the difference between the Gross enrolment ratio (%) of Pre-primary schools in 1995 and the Gross enrolment ratio (%) of Primary schools in 1996?
Ensure brevity in your answer.  -58.57. What is the difference between the Gross enrolment ratio (%) of Pre-primary schools in 1995 and the Gross enrolment ratio (%) of Secondary schools in 1996?
Give a very brief answer. -47.85. What is the difference between the Gross enrolment ratio (%) of Pre-primary schools in 1995 and the Gross enrolment ratio (%) of Tertiary schools in 1996?
Your response must be concise. 20.95. What is the difference between the Gross enrolment ratio (%) in Primary schools in 1995 and the Gross enrolment ratio (%) in Secondary schools in 1996?
Make the answer very short. 5.42. What is the difference between the Gross enrolment ratio (%) of Primary schools in 1995 and the Gross enrolment ratio (%) of Tertiary schools in 1996?
Provide a short and direct response. 74.22. What is the difference between the Gross enrolment ratio (%) in Secondary schools in 1995 and the Gross enrolment ratio (%) in Tertiary schools in 1996?
Your answer should be very brief. 67.44. What is the difference between the Gross enrolment ratio (%) of Pre-primary schools in 1995 and the Gross enrolment ratio (%) of Primary schools in 1997?
Provide a succinct answer. -60.44. What is the difference between the Gross enrolment ratio (%) of Pre-primary schools in 1995 and the Gross enrolment ratio (%) of Secondary schools in 1997?
Ensure brevity in your answer.  -51. What is the difference between the Gross enrolment ratio (%) in Pre-primary schools in 1995 and the Gross enrolment ratio (%) in Tertiary schools in 1997?
Give a very brief answer. 18.17. What is the difference between the Gross enrolment ratio (%) in Primary schools in 1995 and the Gross enrolment ratio (%) in Secondary schools in 1997?
Offer a terse response. 2.27. What is the difference between the Gross enrolment ratio (%) in Primary schools in 1995 and the Gross enrolment ratio (%) in Tertiary schools in 1997?
Your answer should be compact. 71.44. What is the difference between the Gross enrolment ratio (%) in Secondary schools in 1995 and the Gross enrolment ratio (%) in Tertiary schools in 1997?
Offer a terse response. 64.66. What is the difference between the Gross enrolment ratio (%) in Pre-primary schools in 1995 and the Gross enrolment ratio (%) in Primary schools in 1998?
Keep it short and to the point. -60.8. What is the difference between the Gross enrolment ratio (%) in Pre-primary schools in 1995 and the Gross enrolment ratio (%) in Secondary schools in 1998?
Your answer should be compact. -53.82. What is the difference between the Gross enrolment ratio (%) of Pre-primary schools in 1995 and the Gross enrolment ratio (%) of Tertiary schools in 1998?
Offer a terse response. 16.85. What is the difference between the Gross enrolment ratio (%) of Primary schools in 1995 and the Gross enrolment ratio (%) of Secondary schools in 1998?
Your answer should be very brief. -0.55. What is the difference between the Gross enrolment ratio (%) of Primary schools in 1995 and the Gross enrolment ratio (%) of Tertiary schools in 1998?
Make the answer very short. 70.11. What is the difference between the Gross enrolment ratio (%) of Secondary schools in 1995 and the Gross enrolment ratio (%) of Tertiary schools in 1998?
Keep it short and to the point. 63.33. What is the difference between the Gross enrolment ratio (%) of Pre-primary schools in 1995 and the Gross enrolment ratio (%) of Primary schools in 1999?
Give a very brief answer. -61.98. What is the difference between the Gross enrolment ratio (%) in Pre-primary schools in 1995 and the Gross enrolment ratio (%) in Secondary schools in 1999?
Your response must be concise. -57.06. What is the difference between the Gross enrolment ratio (%) in Pre-primary schools in 1995 and the Gross enrolment ratio (%) in Tertiary schools in 1999?
Make the answer very short. 15.48. What is the difference between the Gross enrolment ratio (%) of Primary schools in 1995 and the Gross enrolment ratio (%) of Secondary schools in 1999?
Ensure brevity in your answer.  -3.79. What is the difference between the Gross enrolment ratio (%) of Primary schools in 1995 and the Gross enrolment ratio (%) of Tertiary schools in 1999?
Give a very brief answer. 68.75. What is the difference between the Gross enrolment ratio (%) of Secondary schools in 1995 and the Gross enrolment ratio (%) of Tertiary schools in 1999?
Give a very brief answer. 61.97. What is the difference between the Gross enrolment ratio (%) of Pre-primary schools in 1996 and the Gross enrolment ratio (%) of Primary schools in 1997?
Provide a short and direct response. -53.91. What is the difference between the Gross enrolment ratio (%) in Pre-primary schools in 1996 and the Gross enrolment ratio (%) in Secondary schools in 1997?
Ensure brevity in your answer.  -44.47. What is the difference between the Gross enrolment ratio (%) of Pre-primary schools in 1996 and the Gross enrolment ratio (%) of Tertiary schools in 1997?
Offer a very short reply. 24.7. What is the difference between the Gross enrolment ratio (%) in Primary schools in 1996 and the Gross enrolment ratio (%) in Secondary schools in 1997?
Provide a succinct answer. 7.57. What is the difference between the Gross enrolment ratio (%) in Primary schools in 1996 and the Gross enrolment ratio (%) in Tertiary schools in 1997?
Your answer should be compact. 76.74. What is the difference between the Gross enrolment ratio (%) of Secondary schools in 1996 and the Gross enrolment ratio (%) of Tertiary schools in 1997?
Provide a succinct answer. 66.02. What is the difference between the Gross enrolment ratio (%) in Pre-primary schools in 1996 and the Gross enrolment ratio (%) in Primary schools in 1998?
Your answer should be very brief. -54.27. What is the difference between the Gross enrolment ratio (%) of Pre-primary schools in 1996 and the Gross enrolment ratio (%) of Secondary schools in 1998?
Provide a succinct answer. -47.29. What is the difference between the Gross enrolment ratio (%) in Pre-primary schools in 1996 and the Gross enrolment ratio (%) in Tertiary schools in 1998?
Your answer should be compact. 23.37. What is the difference between the Gross enrolment ratio (%) in Primary schools in 1996 and the Gross enrolment ratio (%) in Secondary schools in 1998?
Your answer should be very brief. 4.75. What is the difference between the Gross enrolment ratio (%) in Primary schools in 1996 and the Gross enrolment ratio (%) in Tertiary schools in 1998?
Offer a terse response. 75.42. What is the difference between the Gross enrolment ratio (%) of Secondary schools in 1996 and the Gross enrolment ratio (%) of Tertiary schools in 1998?
Your answer should be very brief. 64.69. What is the difference between the Gross enrolment ratio (%) in Pre-primary schools in 1996 and the Gross enrolment ratio (%) in Primary schools in 1999?
Your answer should be compact. -55.45. What is the difference between the Gross enrolment ratio (%) in Pre-primary schools in 1996 and the Gross enrolment ratio (%) in Secondary schools in 1999?
Your response must be concise. -50.53. What is the difference between the Gross enrolment ratio (%) of Pre-primary schools in 1996 and the Gross enrolment ratio (%) of Tertiary schools in 1999?
Your answer should be very brief. 22.01. What is the difference between the Gross enrolment ratio (%) in Primary schools in 1996 and the Gross enrolment ratio (%) in Secondary schools in 1999?
Provide a succinct answer. 1.51. What is the difference between the Gross enrolment ratio (%) of Primary schools in 1996 and the Gross enrolment ratio (%) of Tertiary schools in 1999?
Ensure brevity in your answer.  74.05. What is the difference between the Gross enrolment ratio (%) in Secondary schools in 1996 and the Gross enrolment ratio (%) in Tertiary schools in 1999?
Provide a short and direct response. 63.32. What is the difference between the Gross enrolment ratio (%) of Pre-primary schools in 1997 and the Gross enrolment ratio (%) of Primary schools in 1998?
Your answer should be very brief. -50.64. What is the difference between the Gross enrolment ratio (%) of Pre-primary schools in 1997 and the Gross enrolment ratio (%) of Secondary schools in 1998?
Give a very brief answer. -43.66. What is the difference between the Gross enrolment ratio (%) of Pre-primary schools in 1997 and the Gross enrolment ratio (%) of Tertiary schools in 1998?
Offer a terse response. 27. What is the difference between the Gross enrolment ratio (%) of Primary schools in 1997 and the Gross enrolment ratio (%) of Secondary schools in 1998?
Give a very brief answer. 6.62. What is the difference between the Gross enrolment ratio (%) in Primary schools in 1997 and the Gross enrolment ratio (%) in Tertiary schools in 1998?
Ensure brevity in your answer.  77.28. What is the difference between the Gross enrolment ratio (%) in Secondary schools in 1997 and the Gross enrolment ratio (%) in Tertiary schools in 1998?
Give a very brief answer. 67.85. What is the difference between the Gross enrolment ratio (%) in Pre-primary schools in 1997 and the Gross enrolment ratio (%) in Primary schools in 1999?
Offer a terse response. -51.83. What is the difference between the Gross enrolment ratio (%) of Pre-primary schools in 1997 and the Gross enrolment ratio (%) of Secondary schools in 1999?
Provide a short and direct response. -46.9. What is the difference between the Gross enrolment ratio (%) of Pre-primary schools in 1997 and the Gross enrolment ratio (%) of Tertiary schools in 1999?
Your answer should be compact. 25.63. What is the difference between the Gross enrolment ratio (%) of Primary schools in 1997 and the Gross enrolment ratio (%) of Secondary schools in 1999?
Give a very brief answer. 3.38. What is the difference between the Gross enrolment ratio (%) in Primary schools in 1997 and the Gross enrolment ratio (%) in Tertiary schools in 1999?
Offer a terse response. 75.91. What is the difference between the Gross enrolment ratio (%) of Secondary schools in 1997 and the Gross enrolment ratio (%) of Tertiary schools in 1999?
Offer a very short reply. 66.48. What is the difference between the Gross enrolment ratio (%) in Pre-primary schools in 1998 and the Gross enrolment ratio (%) in Primary schools in 1999?
Provide a short and direct response. -49.35. What is the difference between the Gross enrolment ratio (%) in Pre-primary schools in 1998 and the Gross enrolment ratio (%) in Secondary schools in 1999?
Your answer should be very brief. -44.42. What is the difference between the Gross enrolment ratio (%) in Pre-primary schools in 1998 and the Gross enrolment ratio (%) in Tertiary schools in 1999?
Your answer should be compact. 28.11. What is the difference between the Gross enrolment ratio (%) of Primary schools in 1998 and the Gross enrolment ratio (%) of Secondary schools in 1999?
Your answer should be compact. 3.74. What is the difference between the Gross enrolment ratio (%) in Primary schools in 1998 and the Gross enrolment ratio (%) in Tertiary schools in 1999?
Offer a terse response. 76.28. What is the difference between the Gross enrolment ratio (%) in Secondary schools in 1998 and the Gross enrolment ratio (%) in Tertiary schools in 1999?
Keep it short and to the point. 69.29. What is the average Gross enrolment ratio (%) in Pre-primary schools per year?
Give a very brief answer. 42.6. What is the average Gross enrolment ratio (%) of Primary schools per year?
Keep it short and to the point. 94.65. What is the average Gross enrolment ratio (%) of Secondary schools per year?
Provide a succinct answer. 87.66. What is the average Gross enrolment ratio (%) in Tertiary schools per year?
Provide a succinct answer. 19.38. In the year 1991, what is the difference between the Gross enrolment ratio (%) in Pre-primary schools and Gross enrolment ratio (%) in Primary schools?
Keep it short and to the point. -51.6. In the year 1991, what is the difference between the Gross enrolment ratio (%) in Pre-primary schools and Gross enrolment ratio (%) in Secondary schools?
Your answer should be very brief. -39.69. In the year 1991, what is the difference between the Gross enrolment ratio (%) in Pre-primary schools and Gross enrolment ratio (%) in Tertiary schools?
Provide a short and direct response. 27.19. In the year 1991, what is the difference between the Gross enrolment ratio (%) in Primary schools and Gross enrolment ratio (%) in Secondary schools?
Offer a terse response. 11.9. In the year 1991, what is the difference between the Gross enrolment ratio (%) in Primary schools and Gross enrolment ratio (%) in Tertiary schools?
Provide a short and direct response. 78.78. In the year 1991, what is the difference between the Gross enrolment ratio (%) in Secondary schools and Gross enrolment ratio (%) in Tertiary schools?
Give a very brief answer. 66.88. In the year 1992, what is the difference between the Gross enrolment ratio (%) in Pre-primary schools and Gross enrolment ratio (%) in Primary schools?
Your response must be concise. -52.78. In the year 1992, what is the difference between the Gross enrolment ratio (%) of Pre-primary schools and Gross enrolment ratio (%) of Secondary schools?
Offer a very short reply. -48.04. In the year 1992, what is the difference between the Gross enrolment ratio (%) in Pre-primary schools and Gross enrolment ratio (%) in Tertiary schools?
Provide a short and direct response. 18.62. In the year 1992, what is the difference between the Gross enrolment ratio (%) in Primary schools and Gross enrolment ratio (%) in Secondary schools?
Give a very brief answer. 4.74. In the year 1992, what is the difference between the Gross enrolment ratio (%) in Primary schools and Gross enrolment ratio (%) in Tertiary schools?
Give a very brief answer. 71.4. In the year 1992, what is the difference between the Gross enrolment ratio (%) of Secondary schools and Gross enrolment ratio (%) of Tertiary schools?
Your answer should be very brief. 66.65. In the year 1993, what is the difference between the Gross enrolment ratio (%) of Pre-primary schools and Gross enrolment ratio (%) of Primary schools?
Your response must be concise. -58.73. In the year 1993, what is the difference between the Gross enrolment ratio (%) of Pre-primary schools and Gross enrolment ratio (%) of Secondary schools?
Your answer should be compact. -55.99. In the year 1993, what is the difference between the Gross enrolment ratio (%) of Pre-primary schools and Gross enrolment ratio (%) of Tertiary schools?
Make the answer very short. 10.05. In the year 1993, what is the difference between the Gross enrolment ratio (%) of Primary schools and Gross enrolment ratio (%) of Secondary schools?
Provide a short and direct response. 2.74. In the year 1993, what is the difference between the Gross enrolment ratio (%) in Primary schools and Gross enrolment ratio (%) in Tertiary schools?
Ensure brevity in your answer.  68.79. In the year 1993, what is the difference between the Gross enrolment ratio (%) of Secondary schools and Gross enrolment ratio (%) of Tertiary schools?
Your answer should be compact. 66.05. In the year 1994, what is the difference between the Gross enrolment ratio (%) in Pre-primary schools and Gross enrolment ratio (%) in Primary schools?
Make the answer very short. -55.92. In the year 1994, what is the difference between the Gross enrolment ratio (%) of Pre-primary schools and Gross enrolment ratio (%) of Secondary schools?
Ensure brevity in your answer.  -51.19. In the year 1994, what is the difference between the Gross enrolment ratio (%) in Pre-primary schools and Gross enrolment ratio (%) in Tertiary schools?
Offer a very short reply. 14.87. In the year 1994, what is the difference between the Gross enrolment ratio (%) in Primary schools and Gross enrolment ratio (%) in Secondary schools?
Offer a terse response. 4.73. In the year 1994, what is the difference between the Gross enrolment ratio (%) in Primary schools and Gross enrolment ratio (%) in Tertiary schools?
Your response must be concise. 70.79. In the year 1994, what is the difference between the Gross enrolment ratio (%) in Secondary schools and Gross enrolment ratio (%) in Tertiary schools?
Your response must be concise. 66.06. In the year 1995, what is the difference between the Gross enrolment ratio (%) of Pre-primary schools and Gross enrolment ratio (%) of Primary schools?
Keep it short and to the point. -53.27. In the year 1995, what is the difference between the Gross enrolment ratio (%) of Pre-primary schools and Gross enrolment ratio (%) of Secondary schools?
Give a very brief answer. -46.49. In the year 1995, what is the difference between the Gross enrolment ratio (%) in Pre-primary schools and Gross enrolment ratio (%) in Tertiary schools?
Offer a very short reply. 21.19. In the year 1995, what is the difference between the Gross enrolment ratio (%) in Primary schools and Gross enrolment ratio (%) in Secondary schools?
Your answer should be compact. 6.78. In the year 1995, what is the difference between the Gross enrolment ratio (%) of Primary schools and Gross enrolment ratio (%) of Tertiary schools?
Make the answer very short. 74.46. In the year 1995, what is the difference between the Gross enrolment ratio (%) of Secondary schools and Gross enrolment ratio (%) of Tertiary schools?
Ensure brevity in your answer.  67.68. In the year 1996, what is the difference between the Gross enrolment ratio (%) in Pre-primary schools and Gross enrolment ratio (%) in Primary schools?
Ensure brevity in your answer.  -52.04. In the year 1996, what is the difference between the Gross enrolment ratio (%) of Pre-primary schools and Gross enrolment ratio (%) of Secondary schools?
Ensure brevity in your answer.  -41.32. In the year 1996, what is the difference between the Gross enrolment ratio (%) of Pre-primary schools and Gross enrolment ratio (%) of Tertiary schools?
Offer a very short reply. 27.48. In the year 1996, what is the difference between the Gross enrolment ratio (%) in Primary schools and Gross enrolment ratio (%) in Secondary schools?
Keep it short and to the point. 10.72. In the year 1996, what is the difference between the Gross enrolment ratio (%) of Primary schools and Gross enrolment ratio (%) of Tertiary schools?
Offer a terse response. 79.52. In the year 1996, what is the difference between the Gross enrolment ratio (%) of Secondary schools and Gross enrolment ratio (%) of Tertiary schools?
Make the answer very short. 68.8. In the year 1997, what is the difference between the Gross enrolment ratio (%) of Pre-primary schools and Gross enrolment ratio (%) of Primary schools?
Offer a terse response. -50.28. In the year 1997, what is the difference between the Gross enrolment ratio (%) in Pre-primary schools and Gross enrolment ratio (%) in Secondary schools?
Provide a succinct answer. -40.85. In the year 1997, what is the difference between the Gross enrolment ratio (%) in Pre-primary schools and Gross enrolment ratio (%) in Tertiary schools?
Make the answer very short. 28.33. In the year 1997, what is the difference between the Gross enrolment ratio (%) of Primary schools and Gross enrolment ratio (%) of Secondary schools?
Give a very brief answer. 9.43. In the year 1997, what is the difference between the Gross enrolment ratio (%) of Primary schools and Gross enrolment ratio (%) of Tertiary schools?
Ensure brevity in your answer.  78.61. In the year 1997, what is the difference between the Gross enrolment ratio (%) of Secondary schools and Gross enrolment ratio (%) of Tertiary schools?
Provide a short and direct response. 69.18. In the year 1998, what is the difference between the Gross enrolment ratio (%) in Pre-primary schools and Gross enrolment ratio (%) in Primary schools?
Ensure brevity in your answer.  -48.17. In the year 1998, what is the difference between the Gross enrolment ratio (%) in Pre-primary schools and Gross enrolment ratio (%) in Secondary schools?
Offer a very short reply. -41.18. In the year 1998, what is the difference between the Gross enrolment ratio (%) of Pre-primary schools and Gross enrolment ratio (%) of Tertiary schools?
Your answer should be compact. 29.48. In the year 1998, what is the difference between the Gross enrolment ratio (%) of Primary schools and Gross enrolment ratio (%) of Secondary schools?
Your response must be concise. 6.98. In the year 1998, what is the difference between the Gross enrolment ratio (%) in Primary schools and Gross enrolment ratio (%) in Tertiary schools?
Your answer should be very brief. 77.64. In the year 1998, what is the difference between the Gross enrolment ratio (%) of Secondary schools and Gross enrolment ratio (%) of Tertiary schools?
Keep it short and to the point. 70.66. In the year 1999, what is the difference between the Gross enrolment ratio (%) of Pre-primary schools and Gross enrolment ratio (%) of Primary schools?
Give a very brief answer. -45.65. In the year 1999, what is the difference between the Gross enrolment ratio (%) of Pre-primary schools and Gross enrolment ratio (%) of Secondary schools?
Your answer should be very brief. -40.73. In the year 1999, what is the difference between the Gross enrolment ratio (%) of Pre-primary schools and Gross enrolment ratio (%) of Tertiary schools?
Keep it short and to the point. 31.81. In the year 1999, what is the difference between the Gross enrolment ratio (%) in Primary schools and Gross enrolment ratio (%) in Secondary schools?
Your response must be concise. 4.92. In the year 1999, what is the difference between the Gross enrolment ratio (%) of Primary schools and Gross enrolment ratio (%) of Tertiary schools?
Your answer should be compact. 77.46. In the year 1999, what is the difference between the Gross enrolment ratio (%) of Secondary schools and Gross enrolment ratio (%) of Tertiary schools?
Your answer should be compact. 72.53. What is the ratio of the Gross enrolment ratio (%) of Pre-primary schools in 1991 to that in 1992?
Give a very brief answer. 1.23. What is the ratio of the Gross enrolment ratio (%) of Primary schools in 1991 to that in 1992?
Ensure brevity in your answer.  1.08. What is the ratio of the Gross enrolment ratio (%) in Secondary schools in 1991 to that in 1992?
Your response must be concise. 1. What is the ratio of the Gross enrolment ratio (%) of Tertiary schools in 1991 to that in 1992?
Your answer should be compact. 1.01. What is the ratio of the Gross enrolment ratio (%) of Pre-primary schools in 1991 to that in 1993?
Offer a very short reply. 1.67. What is the ratio of the Gross enrolment ratio (%) of Primary schools in 1991 to that in 1993?
Your answer should be compact. 1.13. What is the ratio of the Gross enrolment ratio (%) of Secondary schools in 1991 to that in 1993?
Give a very brief answer. 1.03. What is the ratio of the Gross enrolment ratio (%) of Tertiary schools in 1991 to that in 1993?
Offer a very short reply. 1.09. What is the ratio of the Gross enrolment ratio (%) of Pre-primary schools in 1991 to that in 1994?
Your response must be concise. 1.49. What is the ratio of the Gross enrolment ratio (%) in Primary schools in 1991 to that in 1994?
Your response must be concise. 1.13. What is the ratio of the Gross enrolment ratio (%) in Secondary schools in 1991 to that in 1994?
Make the answer very short. 1.05. What is the ratio of the Gross enrolment ratio (%) of Tertiary schools in 1991 to that in 1994?
Offer a very short reply. 1.18. What is the ratio of the Gross enrolment ratio (%) in Pre-primary schools in 1991 to that in 1995?
Keep it short and to the point. 1.2. What is the ratio of the Gross enrolment ratio (%) in Primary schools in 1991 to that in 1995?
Offer a terse response. 1.06. What is the ratio of the Gross enrolment ratio (%) in Tertiary schools in 1991 to that in 1995?
Keep it short and to the point. 1.09. What is the ratio of the Gross enrolment ratio (%) of Pre-primary schools in 1991 to that in 1996?
Provide a short and direct response. 1.02. What is the ratio of the Gross enrolment ratio (%) of Secondary schools in 1991 to that in 1996?
Offer a very short reply. 0.99. What is the ratio of the Gross enrolment ratio (%) of Tertiary schools in 1991 to that in 1996?
Make the answer very short. 1.08. What is the ratio of the Gross enrolment ratio (%) of Pre-primary schools in 1991 to that in 1997?
Ensure brevity in your answer.  0.95. What is the ratio of the Gross enrolment ratio (%) of Secondary schools in 1991 to that in 1997?
Give a very brief answer. 0.96. What is the ratio of the Gross enrolment ratio (%) of Tertiary schools in 1991 to that in 1997?
Provide a short and direct response. 0.93. What is the ratio of the Gross enrolment ratio (%) of Pre-primary schools in 1991 to that in 1998?
Give a very brief answer. 0.9. What is the ratio of the Gross enrolment ratio (%) in Primary schools in 1991 to that in 1998?
Make the answer very short. 0.98. What is the ratio of the Gross enrolment ratio (%) of Secondary schools in 1991 to that in 1998?
Offer a terse response. 0.93. What is the ratio of the Gross enrolment ratio (%) in Tertiary schools in 1991 to that in 1998?
Provide a succinct answer. 0.88. What is the ratio of the Gross enrolment ratio (%) in Pre-primary schools in 1991 to that in 1999?
Keep it short and to the point. 0.84. What is the ratio of the Gross enrolment ratio (%) of Primary schools in 1991 to that in 1999?
Your answer should be very brief. 0.97. What is the ratio of the Gross enrolment ratio (%) of Secondary schools in 1991 to that in 1999?
Provide a succinct answer. 0.9. What is the ratio of the Gross enrolment ratio (%) of Tertiary schools in 1991 to that in 1999?
Keep it short and to the point. 0.83. What is the ratio of the Gross enrolment ratio (%) in Pre-primary schools in 1992 to that in 1993?
Keep it short and to the point. 1.36. What is the ratio of the Gross enrolment ratio (%) in Primary schools in 1992 to that in 1993?
Offer a terse response. 1.05. What is the ratio of the Gross enrolment ratio (%) in Secondary schools in 1992 to that in 1993?
Your response must be concise. 1.02. What is the ratio of the Gross enrolment ratio (%) of Tertiary schools in 1992 to that in 1993?
Your answer should be very brief. 1.08. What is the ratio of the Gross enrolment ratio (%) of Pre-primary schools in 1992 to that in 1994?
Your answer should be compact. 1.21. What is the ratio of the Gross enrolment ratio (%) in Primary schools in 1992 to that in 1994?
Provide a short and direct response. 1.04. What is the ratio of the Gross enrolment ratio (%) of Secondary schools in 1992 to that in 1994?
Give a very brief answer. 1.04. What is the ratio of the Gross enrolment ratio (%) in Tertiary schools in 1992 to that in 1994?
Offer a terse response. 1.17. What is the ratio of the Gross enrolment ratio (%) in Pre-primary schools in 1992 to that in 1995?
Offer a very short reply. 0.97. What is the ratio of the Gross enrolment ratio (%) in Primary schools in 1992 to that in 1995?
Your answer should be very brief. 0.98. What is the ratio of the Gross enrolment ratio (%) in Secondary schools in 1992 to that in 1995?
Your response must be concise. 1.01. What is the ratio of the Gross enrolment ratio (%) in Tertiary schools in 1992 to that in 1995?
Offer a terse response. 1.08. What is the ratio of the Gross enrolment ratio (%) in Pre-primary schools in 1992 to that in 1996?
Keep it short and to the point. 0.83. What is the ratio of the Gross enrolment ratio (%) of Primary schools in 1992 to that in 1996?
Ensure brevity in your answer.  0.93. What is the ratio of the Gross enrolment ratio (%) in Secondary schools in 1992 to that in 1996?
Offer a very short reply. 0.99. What is the ratio of the Gross enrolment ratio (%) of Tertiary schools in 1992 to that in 1996?
Give a very brief answer. 1.07. What is the ratio of the Gross enrolment ratio (%) in Pre-primary schools in 1992 to that in 1997?
Make the answer very short. 0.77. What is the ratio of the Gross enrolment ratio (%) in Primary schools in 1992 to that in 1997?
Your answer should be very brief. 0.91. What is the ratio of the Gross enrolment ratio (%) in Secondary schools in 1992 to that in 1997?
Your response must be concise. 0.95. What is the ratio of the Gross enrolment ratio (%) of Tertiary schools in 1992 to that in 1997?
Provide a succinct answer. 0.93. What is the ratio of the Gross enrolment ratio (%) in Pre-primary schools in 1992 to that in 1998?
Offer a very short reply. 0.73. What is the ratio of the Gross enrolment ratio (%) in Primary schools in 1992 to that in 1998?
Your answer should be compact. 0.91. What is the ratio of the Gross enrolment ratio (%) in Secondary schools in 1992 to that in 1998?
Ensure brevity in your answer.  0.93. What is the ratio of the Gross enrolment ratio (%) in Tertiary schools in 1992 to that in 1998?
Give a very brief answer. 0.87. What is the ratio of the Gross enrolment ratio (%) of Pre-primary schools in 1992 to that in 1999?
Your answer should be very brief. 0.68. What is the ratio of the Gross enrolment ratio (%) in Primary schools in 1992 to that in 1999?
Your response must be concise. 0.9. What is the ratio of the Gross enrolment ratio (%) in Secondary schools in 1992 to that in 1999?
Offer a very short reply. 0.89. What is the ratio of the Gross enrolment ratio (%) of Tertiary schools in 1992 to that in 1999?
Provide a succinct answer. 0.82. What is the ratio of the Gross enrolment ratio (%) of Pre-primary schools in 1993 to that in 1994?
Your answer should be very brief. 0.89. What is the ratio of the Gross enrolment ratio (%) in Primary schools in 1993 to that in 1994?
Your answer should be compact. 0.99. What is the ratio of the Gross enrolment ratio (%) in Secondary schools in 1993 to that in 1994?
Ensure brevity in your answer.  1.02. What is the ratio of the Gross enrolment ratio (%) in Tertiary schools in 1993 to that in 1994?
Keep it short and to the point. 1.08. What is the ratio of the Gross enrolment ratio (%) in Pre-primary schools in 1993 to that in 1995?
Offer a terse response. 0.72. What is the ratio of the Gross enrolment ratio (%) in Primary schools in 1993 to that in 1995?
Give a very brief answer. 0.94. What is the ratio of the Gross enrolment ratio (%) in Secondary schools in 1993 to that in 1995?
Provide a short and direct response. 0.98. What is the ratio of the Gross enrolment ratio (%) of Tertiary schools in 1993 to that in 1995?
Make the answer very short. 1. What is the ratio of the Gross enrolment ratio (%) of Pre-primary schools in 1993 to that in 1996?
Provide a succinct answer. 0.61. What is the ratio of the Gross enrolment ratio (%) of Primary schools in 1993 to that in 1996?
Give a very brief answer. 0.89. What is the ratio of the Gross enrolment ratio (%) of Secondary schools in 1993 to that in 1996?
Your answer should be very brief. 0.97. What is the ratio of the Gross enrolment ratio (%) of Tertiary schools in 1993 to that in 1996?
Provide a short and direct response. 0.99. What is the ratio of the Gross enrolment ratio (%) in Pre-primary schools in 1993 to that in 1997?
Provide a succinct answer. 0.57. What is the ratio of the Gross enrolment ratio (%) of Primary schools in 1993 to that in 1997?
Ensure brevity in your answer.  0.87. What is the ratio of the Gross enrolment ratio (%) of Secondary schools in 1993 to that in 1997?
Give a very brief answer. 0.93. What is the ratio of the Gross enrolment ratio (%) in Tertiary schools in 1993 to that in 1997?
Your answer should be very brief. 0.86. What is the ratio of the Gross enrolment ratio (%) in Pre-primary schools in 1993 to that in 1998?
Give a very brief answer. 0.54. What is the ratio of the Gross enrolment ratio (%) in Primary schools in 1993 to that in 1998?
Your answer should be very brief. 0.87. What is the ratio of the Gross enrolment ratio (%) in Secondary schools in 1993 to that in 1998?
Ensure brevity in your answer.  0.9. What is the ratio of the Gross enrolment ratio (%) of Tertiary schools in 1993 to that in 1998?
Keep it short and to the point. 0.81. What is the ratio of the Gross enrolment ratio (%) of Pre-primary schools in 1993 to that in 1999?
Your response must be concise. 0.5. What is the ratio of the Gross enrolment ratio (%) of Primary schools in 1993 to that in 1999?
Keep it short and to the point. 0.86. What is the ratio of the Gross enrolment ratio (%) of Secondary schools in 1993 to that in 1999?
Offer a terse response. 0.87. What is the ratio of the Gross enrolment ratio (%) of Tertiary schools in 1993 to that in 1999?
Give a very brief answer. 0.76. What is the ratio of the Gross enrolment ratio (%) of Pre-primary schools in 1994 to that in 1995?
Offer a terse response. 0.8. What is the ratio of the Gross enrolment ratio (%) in Primary schools in 1994 to that in 1995?
Your answer should be very brief. 0.95. What is the ratio of the Gross enrolment ratio (%) of Secondary schools in 1994 to that in 1995?
Offer a very short reply. 0.97. What is the ratio of the Gross enrolment ratio (%) of Tertiary schools in 1994 to that in 1995?
Make the answer very short. 0.93. What is the ratio of the Gross enrolment ratio (%) in Pre-primary schools in 1994 to that in 1996?
Keep it short and to the point. 0.69. What is the ratio of the Gross enrolment ratio (%) in Primary schools in 1994 to that in 1996?
Your answer should be compact. 0.89. What is the ratio of the Gross enrolment ratio (%) in Secondary schools in 1994 to that in 1996?
Your answer should be very brief. 0.95. What is the ratio of the Gross enrolment ratio (%) of Tertiary schools in 1994 to that in 1996?
Your answer should be very brief. 0.92. What is the ratio of the Gross enrolment ratio (%) of Pre-primary schools in 1994 to that in 1997?
Your response must be concise. 0.64. What is the ratio of the Gross enrolment ratio (%) in Primary schools in 1994 to that in 1997?
Ensure brevity in your answer.  0.88. What is the ratio of the Gross enrolment ratio (%) of Secondary schools in 1994 to that in 1997?
Keep it short and to the point. 0.92. What is the ratio of the Gross enrolment ratio (%) in Tertiary schools in 1994 to that in 1997?
Offer a terse response. 0.79. What is the ratio of the Gross enrolment ratio (%) in Pre-primary schools in 1994 to that in 1998?
Your answer should be compact. 0.61. What is the ratio of the Gross enrolment ratio (%) in Primary schools in 1994 to that in 1998?
Ensure brevity in your answer.  0.87. What is the ratio of the Gross enrolment ratio (%) of Secondary schools in 1994 to that in 1998?
Offer a very short reply. 0.89. What is the ratio of the Gross enrolment ratio (%) of Tertiary schools in 1994 to that in 1998?
Keep it short and to the point. 0.74. What is the ratio of the Gross enrolment ratio (%) of Pre-primary schools in 1994 to that in 1999?
Give a very brief answer. 0.57. What is the ratio of the Gross enrolment ratio (%) in Primary schools in 1994 to that in 1999?
Ensure brevity in your answer.  0.86. What is the ratio of the Gross enrolment ratio (%) in Secondary schools in 1994 to that in 1999?
Ensure brevity in your answer.  0.86. What is the ratio of the Gross enrolment ratio (%) in Tertiary schools in 1994 to that in 1999?
Give a very brief answer. 0.7. What is the ratio of the Gross enrolment ratio (%) of Pre-primary schools in 1995 to that in 1996?
Provide a short and direct response. 0.86. What is the ratio of the Gross enrolment ratio (%) in Primary schools in 1995 to that in 1996?
Ensure brevity in your answer.  0.95. What is the ratio of the Gross enrolment ratio (%) of Secondary schools in 1995 to that in 1996?
Your answer should be compact. 0.98. What is the ratio of the Gross enrolment ratio (%) of Tertiary schools in 1995 to that in 1996?
Make the answer very short. 0.99. What is the ratio of the Gross enrolment ratio (%) in Pre-primary schools in 1995 to that in 1997?
Make the answer very short. 0.79. What is the ratio of the Gross enrolment ratio (%) in Primary schools in 1995 to that in 1997?
Your answer should be very brief. 0.93. What is the ratio of the Gross enrolment ratio (%) of Secondary schools in 1995 to that in 1997?
Give a very brief answer. 0.95. What is the ratio of the Gross enrolment ratio (%) in Tertiary schools in 1995 to that in 1997?
Your answer should be compact. 0.85. What is the ratio of the Gross enrolment ratio (%) of Pre-primary schools in 1995 to that in 1998?
Offer a very short reply. 0.75. What is the ratio of the Gross enrolment ratio (%) in Primary schools in 1995 to that in 1998?
Give a very brief answer. 0.92. What is the ratio of the Gross enrolment ratio (%) of Secondary schools in 1995 to that in 1998?
Your answer should be compact. 0.92. What is the ratio of the Gross enrolment ratio (%) in Tertiary schools in 1995 to that in 1998?
Offer a very short reply. 0.8. What is the ratio of the Gross enrolment ratio (%) in Pre-primary schools in 1995 to that in 1999?
Keep it short and to the point. 0.7. What is the ratio of the Gross enrolment ratio (%) in Primary schools in 1995 to that in 1999?
Offer a terse response. 0.91. What is the ratio of the Gross enrolment ratio (%) in Secondary schools in 1995 to that in 1999?
Offer a terse response. 0.89. What is the ratio of the Gross enrolment ratio (%) of Tertiary schools in 1995 to that in 1999?
Keep it short and to the point. 0.76. What is the ratio of the Gross enrolment ratio (%) of Pre-primary schools in 1996 to that in 1997?
Give a very brief answer. 0.93. What is the ratio of the Gross enrolment ratio (%) of Primary schools in 1996 to that in 1997?
Ensure brevity in your answer.  0.98. What is the ratio of the Gross enrolment ratio (%) of Secondary schools in 1996 to that in 1997?
Give a very brief answer. 0.96. What is the ratio of the Gross enrolment ratio (%) of Tertiary schools in 1996 to that in 1997?
Ensure brevity in your answer.  0.87. What is the ratio of the Gross enrolment ratio (%) in Pre-primary schools in 1996 to that in 1998?
Provide a short and direct response. 0.88. What is the ratio of the Gross enrolment ratio (%) of Primary schools in 1996 to that in 1998?
Give a very brief answer. 0.98. What is the ratio of the Gross enrolment ratio (%) of Secondary schools in 1996 to that in 1998?
Your answer should be compact. 0.94. What is the ratio of the Gross enrolment ratio (%) in Tertiary schools in 1996 to that in 1998?
Keep it short and to the point. 0.81. What is the ratio of the Gross enrolment ratio (%) in Pre-primary schools in 1996 to that in 1999?
Ensure brevity in your answer.  0.82. What is the ratio of the Gross enrolment ratio (%) of Primary schools in 1996 to that in 1999?
Your answer should be very brief. 0.97. What is the ratio of the Gross enrolment ratio (%) of Secondary schools in 1996 to that in 1999?
Ensure brevity in your answer.  0.9. What is the ratio of the Gross enrolment ratio (%) of Tertiary schools in 1996 to that in 1999?
Provide a short and direct response. 0.77. What is the ratio of the Gross enrolment ratio (%) in Pre-primary schools in 1997 to that in 1998?
Your response must be concise. 0.95. What is the ratio of the Gross enrolment ratio (%) in Secondary schools in 1997 to that in 1998?
Your answer should be compact. 0.97. What is the ratio of the Gross enrolment ratio (%) in Tertiary schools in 1997 to that in 1998?
Keep it short and to the point. 0.94. What is the ratio of the Gross enrolment ratio (%) in Pre-primary schools in 1997 to that in 1999?
Your response must be concise. 0.89. What is the ratio of the Gross enrolment ratio (%) of Primary schools in 1997 to that in 1999?
Your answer should be compact. 0.98. What is the ratio of the Gross enrolment ratio (%) of Secondary schools in 1997 to that in 1999?
Keep it short and to the point. 0.94. What is the ratio of the Gross enrolment ratio (%) in Tertiary schools in 1997 to that in 1999?
Make the answer very short. 0.88. What is the ratio of the Gross enrolment ratio (%) of Pre-primary schools in 1998 to that in 1999?
Offer a very short reply. 0.93. What is the ratio of the Gross enrolment ratio (%) in Primary schools in 1998 to that in 1999?
Provide a succinct answer. 0.99. What is the ratio of the Gross enrolment ratio (%) in Secondary schools in 1998 to that in 1999?
Keep it short and to the point. 0.97. What is the ratio of the Gross enrolment ratio (%) in Tertiary schools in 1998 to that in 1999?
Make the answer very short. 0.94. What is the difference between the highest and the second highest Gross enrolment ratio (%) in Pre-primary schools?
Offer a very short reply. 3.7. What is the difference between the highest and the second highest Gross enrolment ratio (%) in Primary schools?
Keep it short and to the point. 1.18. What is the difference between the highest and the second highest Gross enrolment ratio (%) of Secondary schools?
Offer a very short reply. 3.24. What is the difference between the highest and the second highest Gross enrolment ratio (%) in Tertiary schools?
Make the answer very short. 1.37. What is the difference between the highest and the lowest Gross enrolment ratio (%) of Pre-primary schools?
Ensure brevity in your answer.  27.39. What is the difference between the highest and the lowest Gross enrolment ratio (%) in Primary schools?
Offer a terse response. 14.31. What is the difference between the highest and the lowest Gross enrolment ratio (%) of Secondary schools?
Provide a succinct answer. 13.46. What is the difference between the highest and the lowest Gross enrolment ratio (%) of Tertiary schools?
Keep it short and to the point. 6.99. 